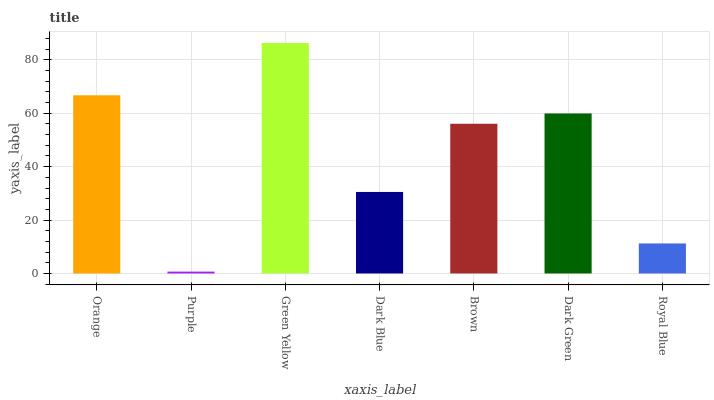Is Purple the minimum?
Answer yes or no. Yes. Is Green Yellow the maximum?
Answer yes or no. Yes. Is Green Yellow the minimum?
Answer yes or no. No. Is Purple the maximum?
Answer yes or no. No. Is Green Yellow greater than Purple?
Answer yes or no. Yes. Is Purple less than Green Yellow?
Answer yes or no. Yes. Is Purple greater than Green Yellow?
Answer yes or no. No. Is Green Yellow less than Purple?
Answer yes or no. No. Is Brown the high median?
Answer yes or no. Yes. Is Brown the low median?
Answer yes or no. Yes. Is Royal Blue the high median?
Answer yes or no. No. Is Green Yellow the low median?
Answer yes or no. No. 